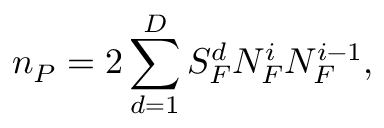Convert formula to latex. <formula><loc_0><loc_0><loc_500><loc_500>n _ { P } = 2 \sum _ { d = 1 } ^ { D } S _ { F } ^ { d } N _ { F } ^ { i } N _ { F } ^ { i - 1 } ,</formula> 